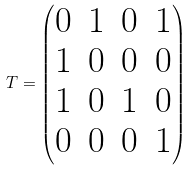<formula> <loc_0><loc_0><loc_500><loc_500>T = \begin{pmatrix} 0 & 1 & 0 & 1 \\ 1 & 0 & 0 & 0 \\ 1 & 0 & 1 & 0 \\ 0 & 0 & 0 & 1 \end{pmatrix}</formula> 